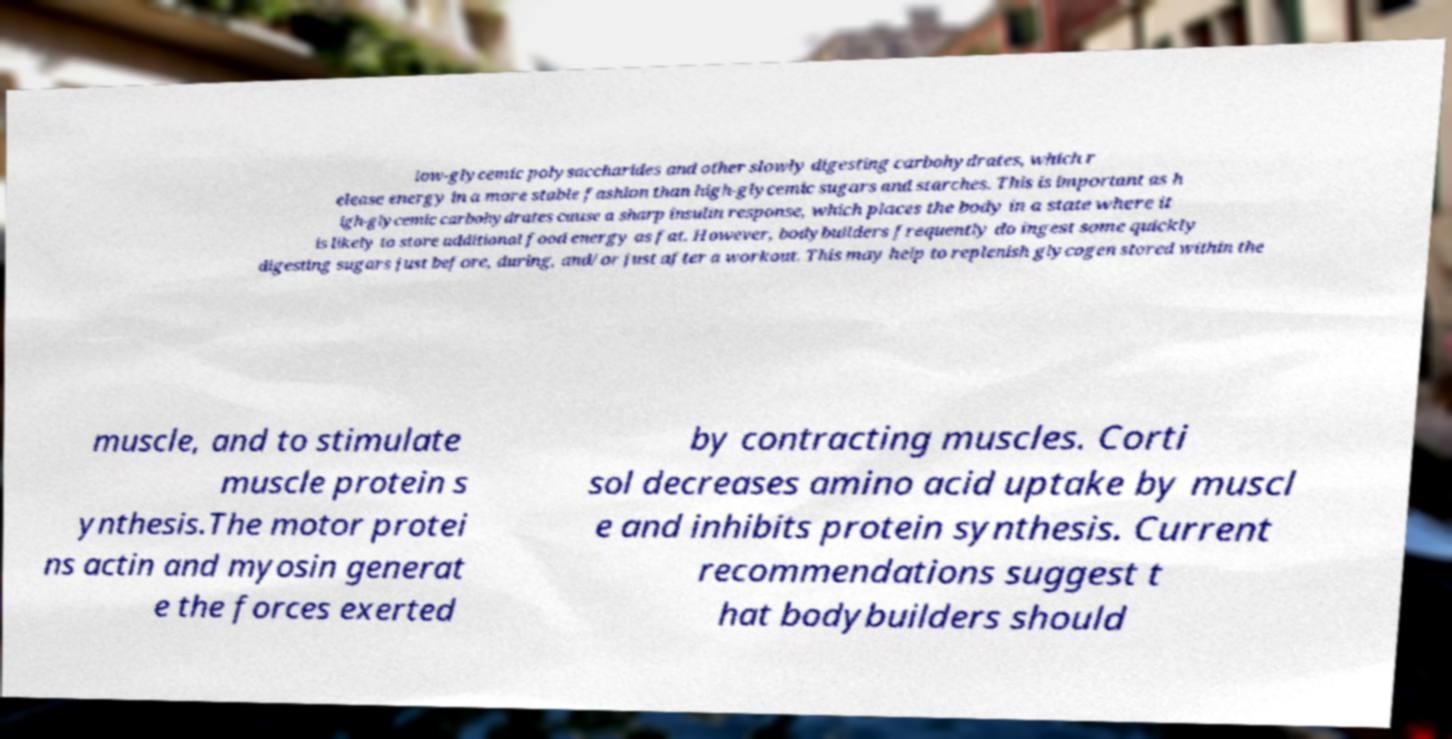Can you read and provide the text displayed in the image?This photo seems to have some interesting text. Can you extract and type it out for me? low-glycemic polysaccharides and other slowly digesting carbohydrates, which r elease energy in a more stable fashion than high-glycemic sugars and starches. This is important as h igh-glycemic carbohydrates cause a sharp insulin response, which places the body in a state where it is likely to store additional food energy as fat. However, bodybuilders frequently do ingest some quickly digesting sugars just before, during, and/or just after a workout. This may help to replenish glycogen stored within the muscle, and to stimulate muscle protein s ynthesis.The motor protei ns actin and myosin generat e the forces exerted by contracting muscles. Corti sol decreases amino acid uptake by muscl e and inhibits protein synthesis. Current recommendations suggest t hat bodybuilders should 